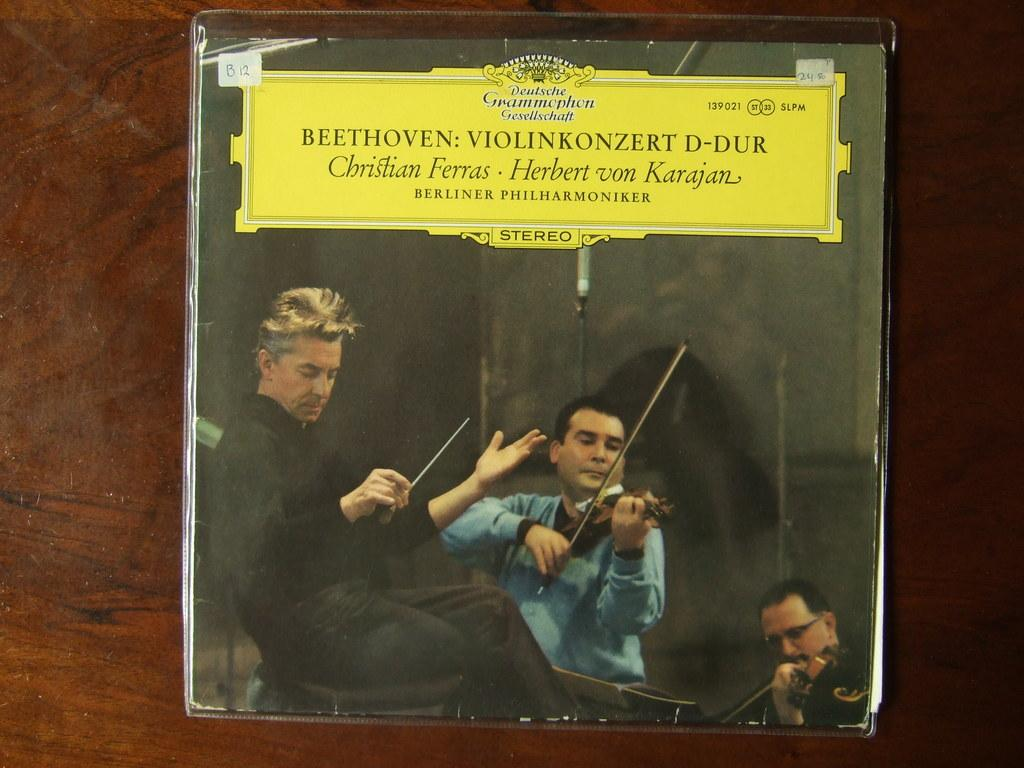What is the main object on the wooden surface in the image? There is a board on the wooden surface in the image. What is depicted on the board? There are people depicted on the board, including two playing musical instruments. What else can be seen on the board? There is text visible on the board. What type of calendar is hanging on the wall behind the board? There is no calendar present in the image; it only features a board on a wooden surface with people and text. 